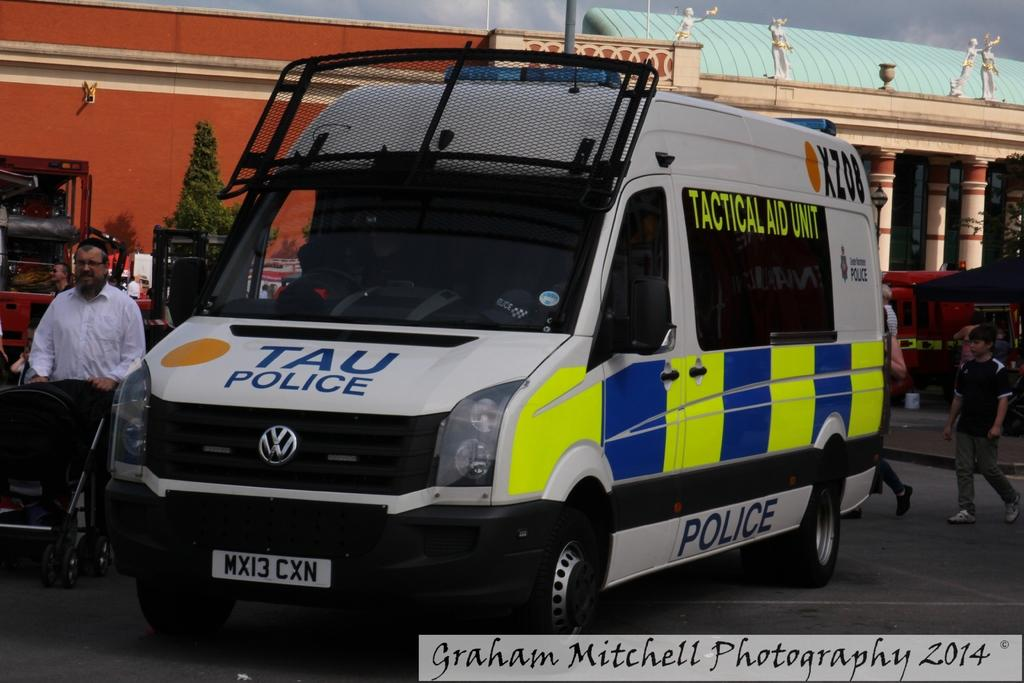<image>
Share a concise interpretation of the image provided. White and blue van that says POLICE on the bottom. 